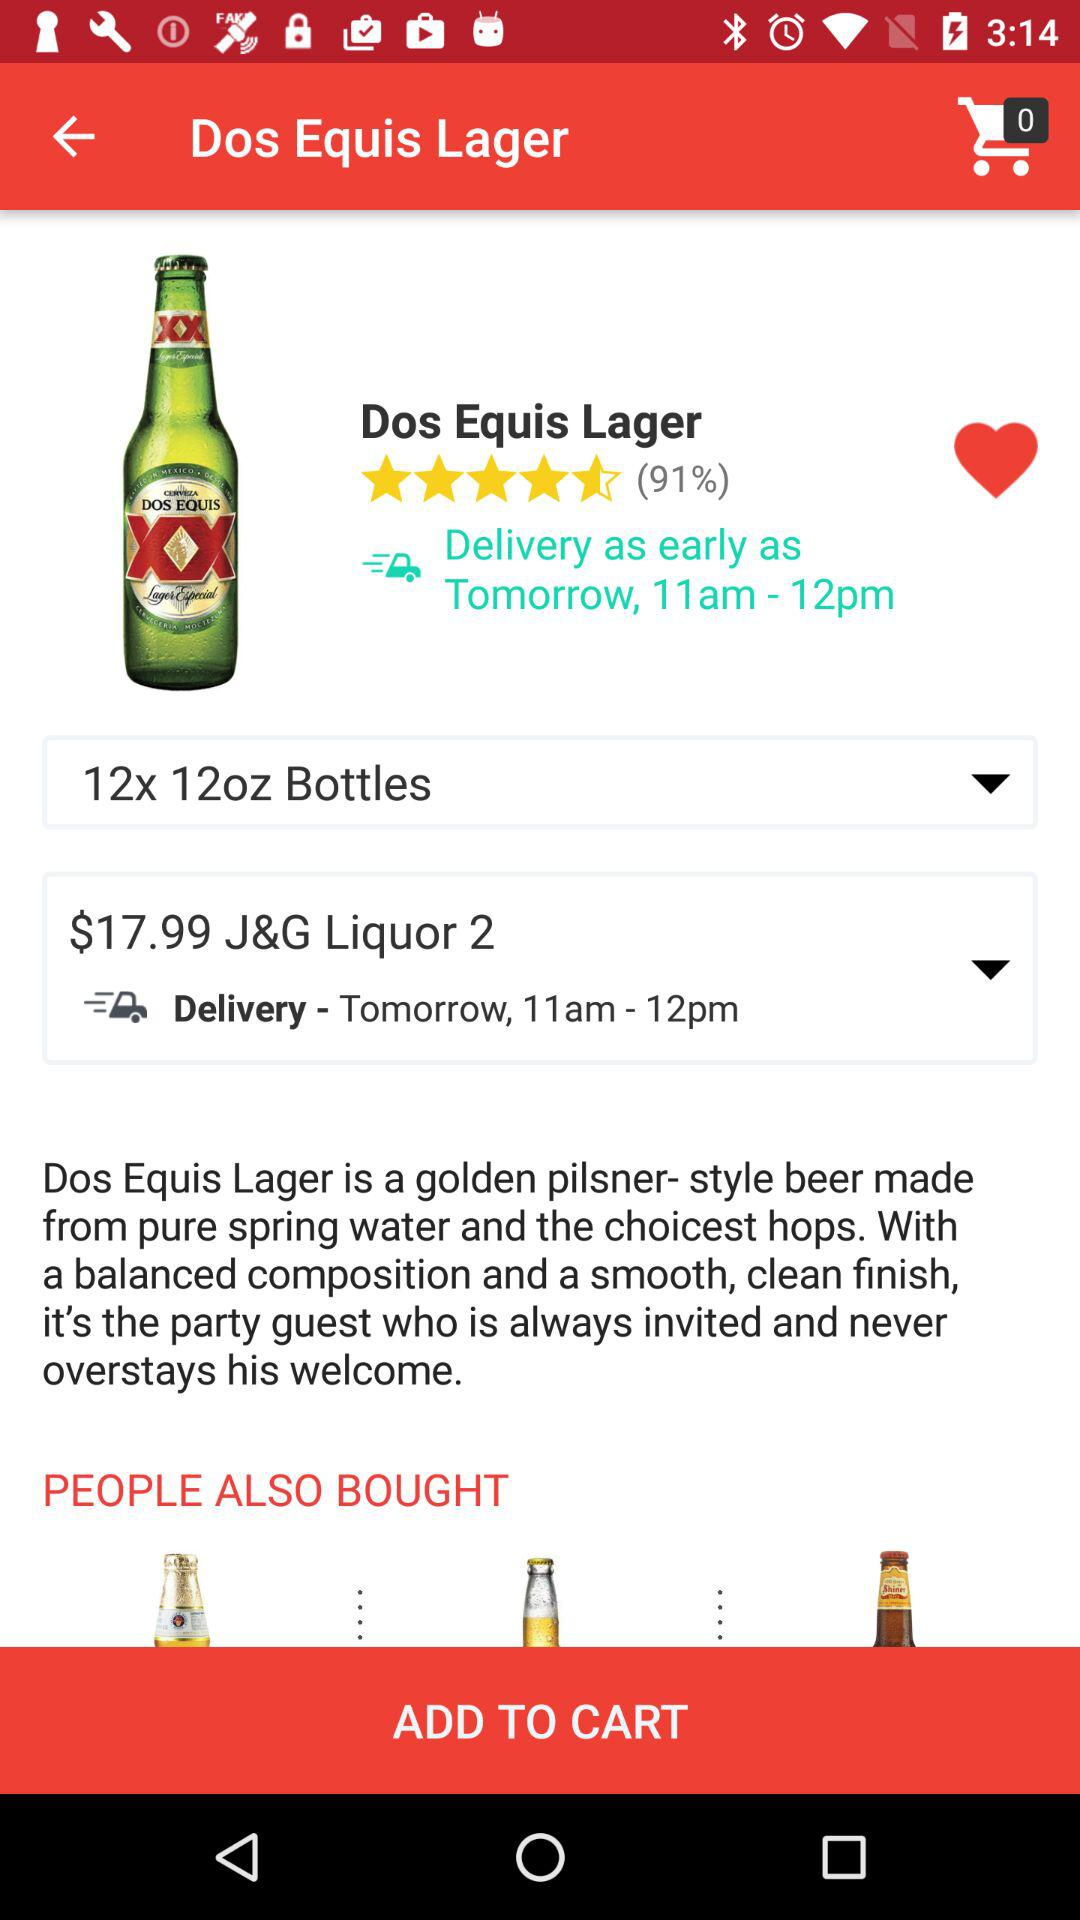How to pronounce the name of the beer?
When the provided information is insufficient, respond with <no answer>. <no answer> 